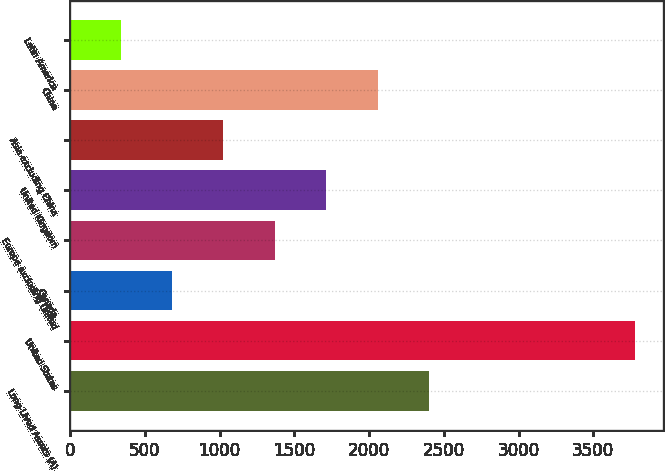<chart> <loc_0><loc_0><loc_500><loc_500><bar_chart><fcel>Long-Lived Assets (A)<fcel>United States<fcel>Canada<fcel>Europe excluding United<fcel>United Kingdom<fcel>Asia excluding China<fcel>China<fcel>Latin America<nl><fcel>2400.94<fcel>3776.7<fcel>681.24<fcel>1369.12<fcel>1713.06<fcel>1025.18<fcel>2057<fcel>337.3<nl></chart> 